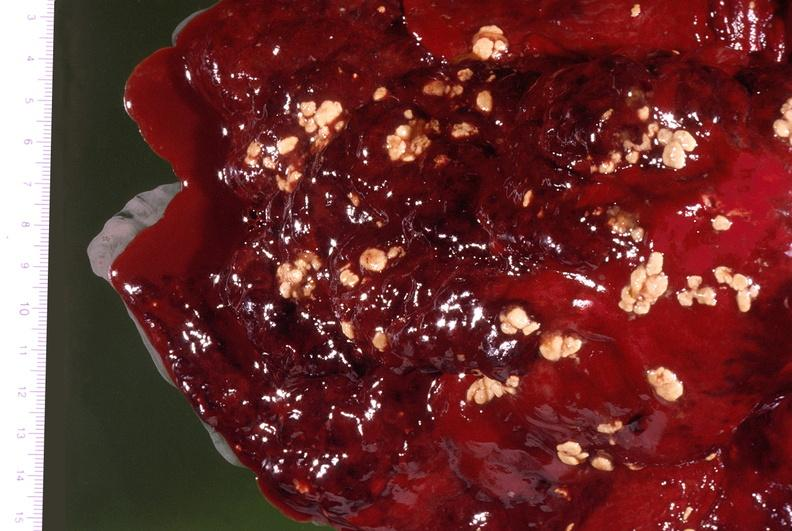s respiratory present?
Answer the question using a single word or phrase. Yes 